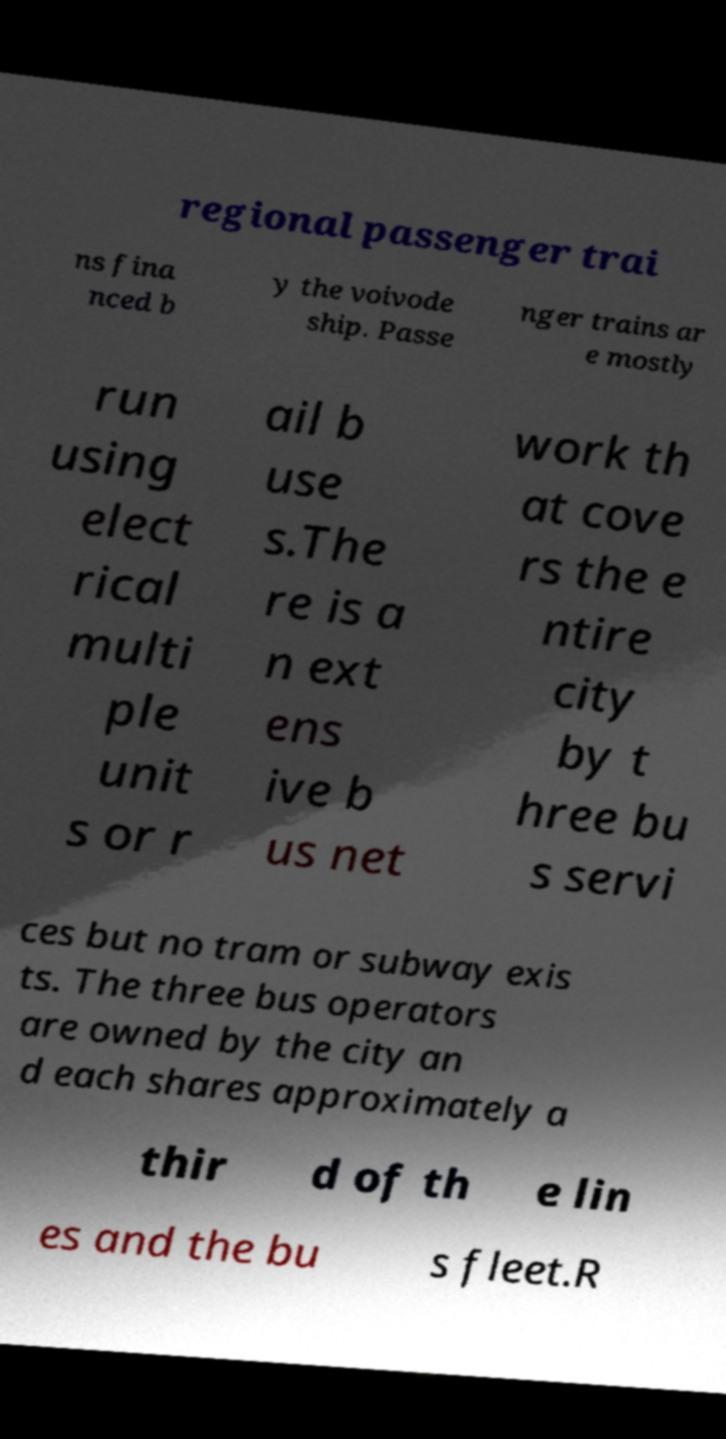For documentation purposes, I need the text within this image transcribed. Could you provide that? regional passenger trai ns fina nced b y the voivode ship. Passe nger trains ar e mostly run using elect rical multi ple unit s or r ail b use s.The re is a n ext ens ive b us net work th at cove rs the e ntire city by t hree bu s servi ces but no tram or subway exis ts. The three bus operators are owned by the city an d each shares approximately a thir d of th e lin es and the bu s fleet.R 